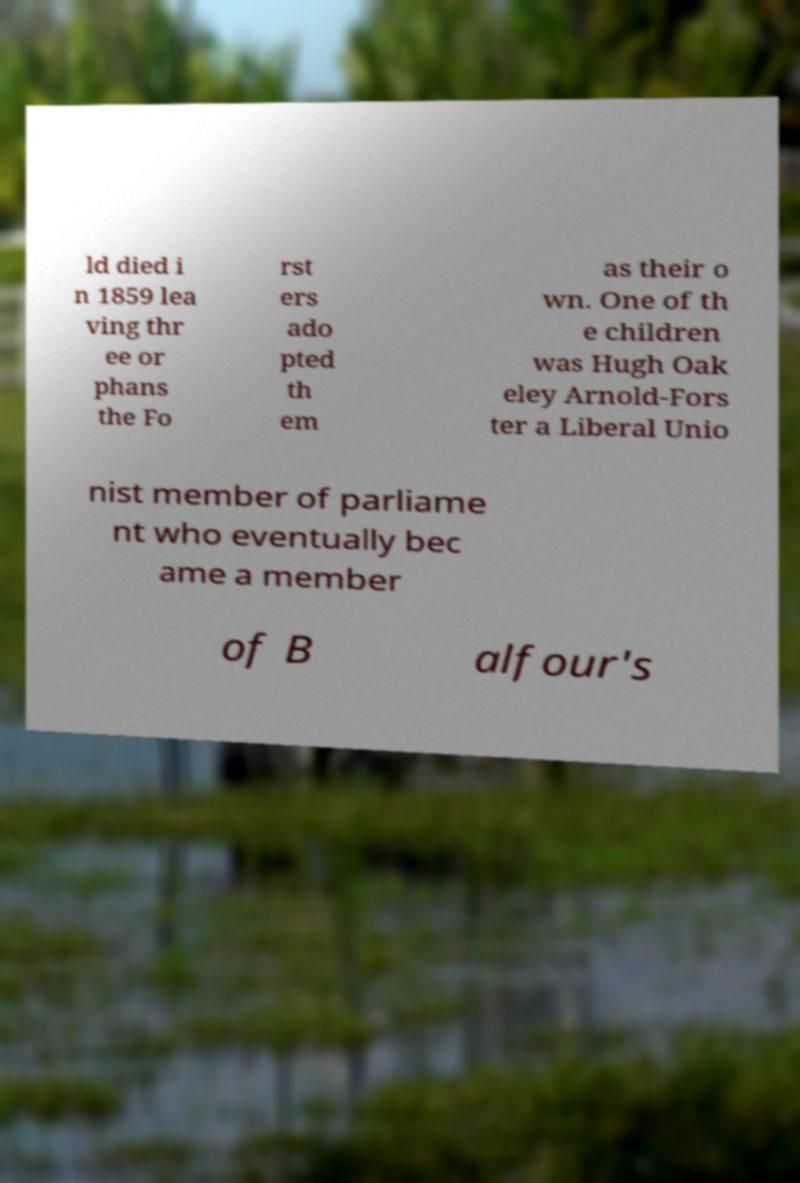There's text embedded in this image that I need extracted. Can you transcribe it verbatim? ld died i n 1859 lea ving thr ee or phans the Fo rst ers ado pted th em as their o wn. One of th e children was Hugh Oak eley Arnold-Fors ter a Liberal Unio nist member of parliame nt who eventually bec ame a member of B alfour's 